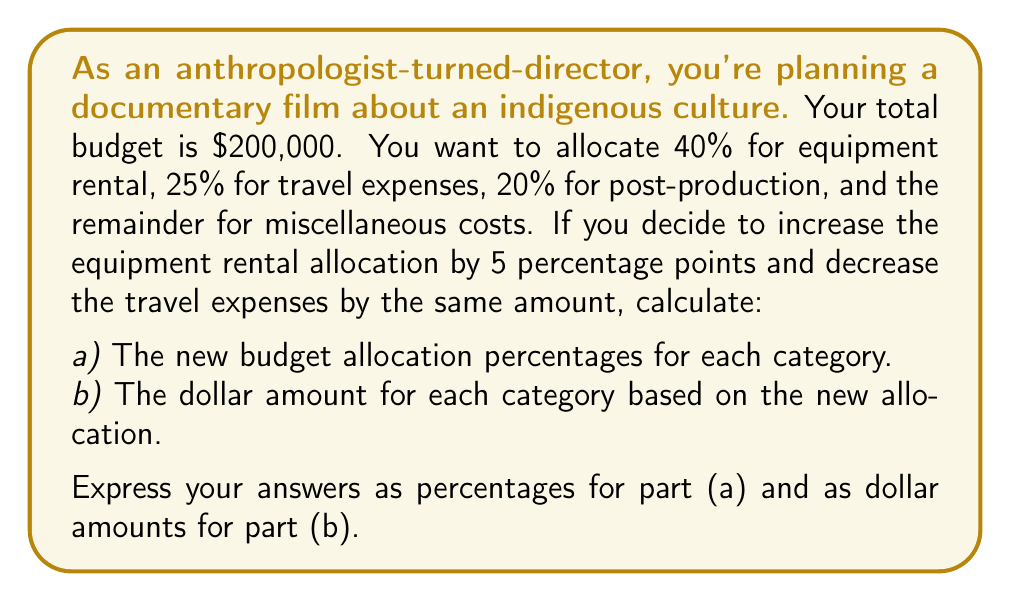Can you solve this math problem? Let's approach this problem step-by-step:

1) Initially, the budget allocation was:
   Equipment rental: 40%
   Travel expenses: 25%
   Post-production: 20%
   Miscellaneous: 100% - (40% + 25% + 20%) = 15%

2) After the 5 percentage point shift:
   Equipment rental: 40% + 5% = 45%
   Travel expenses: 25% - 5% = 20%
   Post-production: Remains at 20%
   Miscellaneous: Remains at 15%

3) To calculate the dollar amounts, we use the formula:
   $\text{Category Amount} = \text{Total Budget} \times \text{Category Percentage}$

   Equipment rental: $200,000 \times 0.45 = $90,000
   Travel expenses: $200,000 \times 0.20 = $40,000
   Post-production: $200,000 \times 0.20 = $40,000
   Miscellaneous: $200,000 \times 0.15 = $30,000

4) Let's verify that these amounts sum to the total budget:
   $90,000 + $40,000 + $40,000 + $30,000 = $200,000

Thus, our calculations are correct and account for the entire budget.
Answer: a) New budget allocation percentages:
   Equipment rental: 45%
   Travel expenses: 20%
   Post-production: 20%
   Miscellaneous: 15%

b) Dollar amounts based on new allocation:
   Equipment rental: $90,000
   Travel expenses: $40,000
   Post-production: $40,000
   Miscellaneous: $30,000 